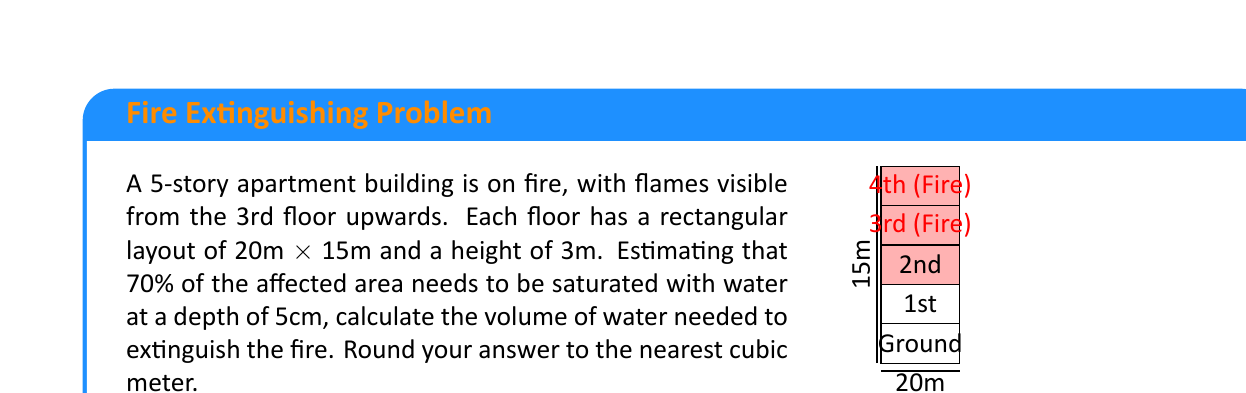Could you help me with this problem? Let's break this down step-by-step:

1) First, we need to calculate the area of each floor:
   $A = 20\text{m} \times 15\text{m} = 300\text{m}^2$

2) The fire affects 3 floors (3rd, 4th, and 5th). So the total affected area is:
   $A_{\text{total}} = 3 \times 300\text{m}^2 = 900\text{m}^2$

3) We need to saturate 70% of this area:
   $A_{\text{saturated}} = 70\% \times 900\text{m}^2 = 0.7 \times 900\text{m}^2 = 630\text{m}^2$

4) The depth of water needed is 5cm, which is 0.05m. To calculate the volume, we multiply the saturated area by this depth:
   $V = A_{\text{saturated}} \times \text{depth} = 630\text{m}^2 \times 0.05\text{m} = 31.5\text{m}^3$

5) Rounding to the nearest cubic meter:
   $31.5\text{m}^3 \approx 32\text{m}^3$

Therefore, approximately 32 cubic meters of water are needed to extinguish the fire.
Answer: $32\text{m}^3$ 